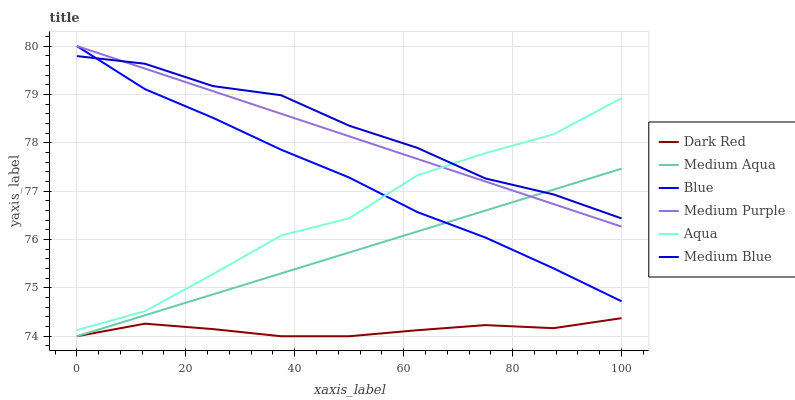Does Aqua have the minimum area under the curve?
Answer yes or no. No. Does Aqua have the maximum area under the curve?
Answer yes or no. No. Is Dark Red the smoothest?
Answer yes or no. No. Is Dark Red the roughest?
Answer yes or no. No. Does Aqua have the lowest value?
Answer yes or no. No. Does Aqua have the highest value?
Answer yes or no. No. Is Dark Red less than Medium Blue?
Answer yes or no. Yes. Is Medium Purple greater than Dark Red?
Answer yes or no. Yes. Does Dark Red intersect Medium Blue?
Answer yes or no. No. 